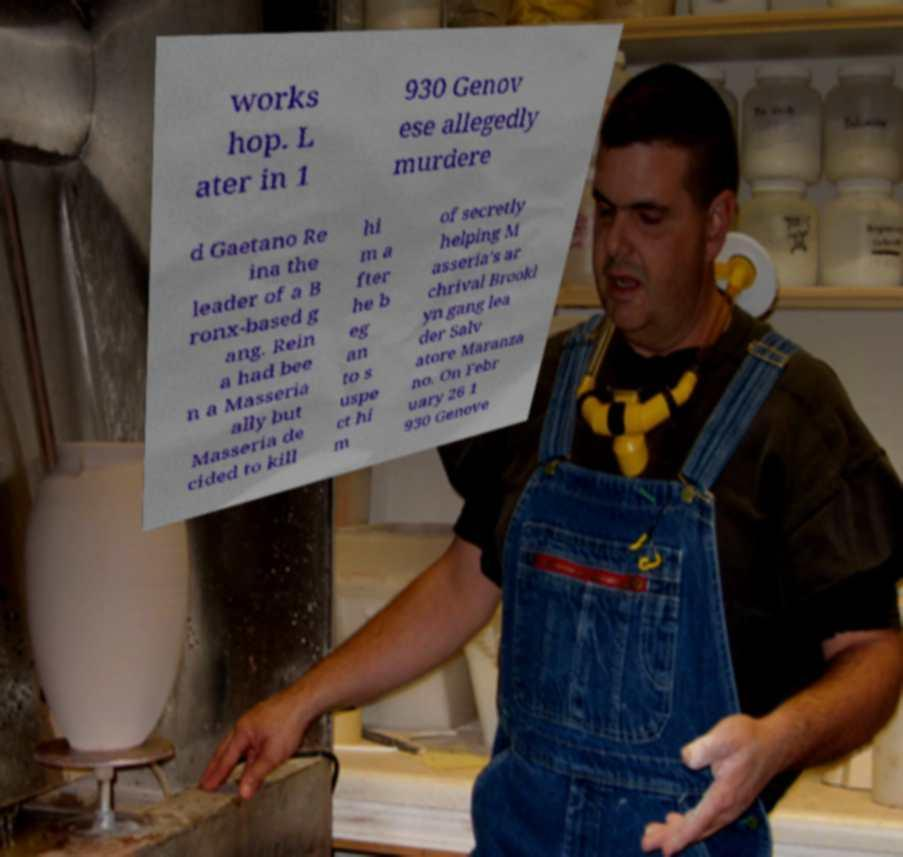There's text embedded in this image that I need extracted. Can you transcribe it verbatim? works hop. L ater in 1 930 Genov ese allegedly murdere d Gaetano Re ina the leader of a B ronx-based g ang. Rein a had bee n a Masseria ally but Masseria de cided to kill hi m a fter he b eg an to s uspe ct hi m of secretly helping M asseria's ar chrival Brookl yn gang lea der Salv atore Maranza no. On Febr uary 26 1 930 Genove 